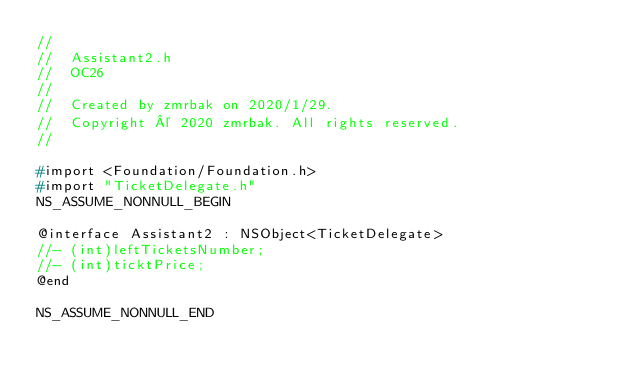Convert code to text. <code><loc_0><loc_0><loc_500><loc_500><_C_>//
//  Assistant2.h
//  OC26
//
//  Created by zmrbak on 2020/1/29.
//  Copyright © 2020 zmrbak. All rights reserved.
//

#import <Foundation/Foundation.h>
#import "TicketDelegate.h"
NS_ASSUME_NONNULL_BEGIN

@interface Assistant2 : NSObject<TicketDelegate>
//- (int)leftTicketsNumber;
//- (int)ticktPrice;
@end

NS_ASSUME_NONNULL_END
</code> 